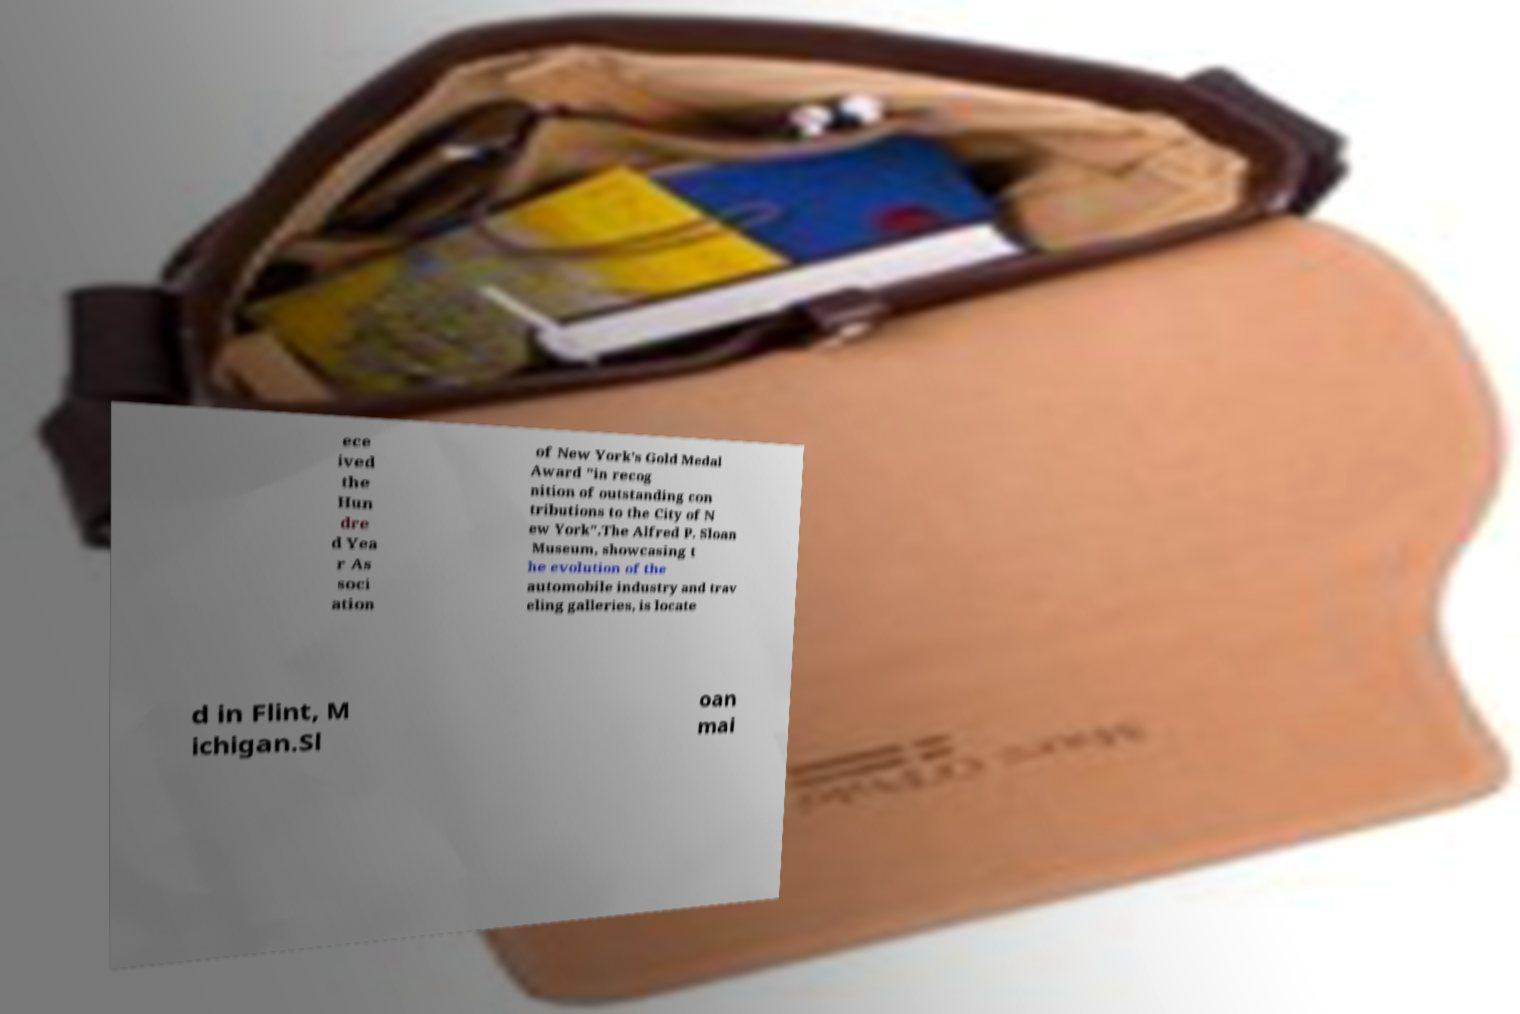There's text embedded in this image that I need extracted. Can you transcribe it verbatim? ece ived the Hun dre d Yea r As soci ation of New York's Gold Medal Award "in recog nition of outstanding con tributions to the City of N ew York".The Alfred P. Sloan Museum, showcasing t he evolution of the automobile industry and trav eling galleries, is locate d in Flint, M ichigan.Sl oan mai 